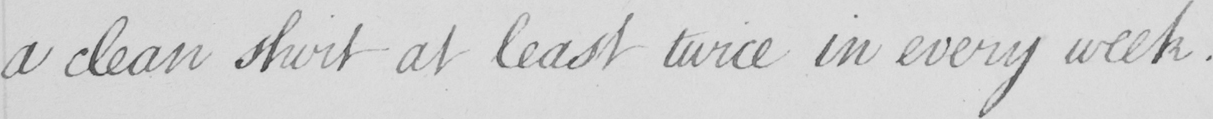Can you read and transcribe this handwriting? a clean shirt at least twice in every week . 